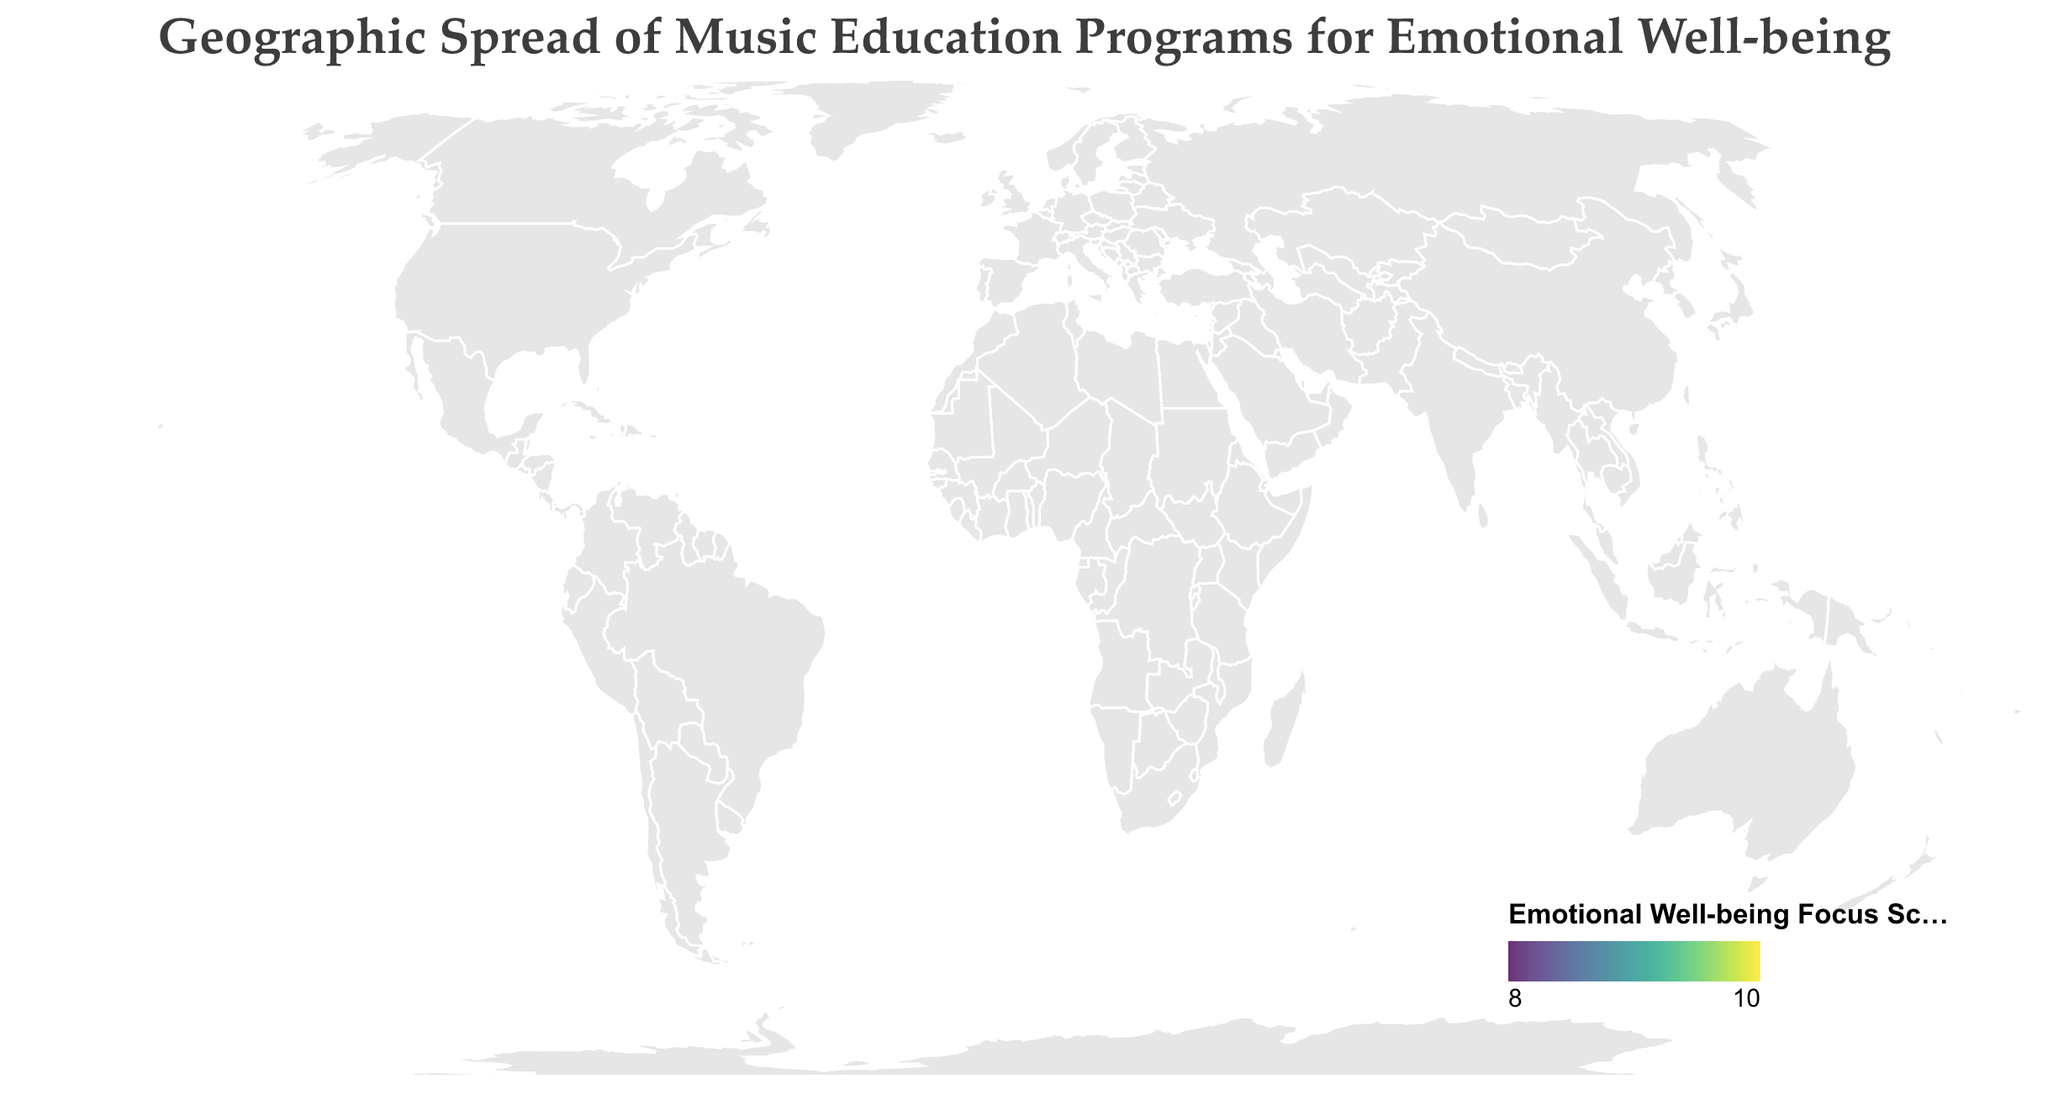What's the title of the figure? The title is displayed at the top of the figure and is written in a prominent font size, making it easy to identify.
Answer: Geographic Spread of Music Education Programs for Emotional Well-being Which city has the highest Emotional Well-being Focus Score? The color gradient representing the Emotional Well-being Focus Score can help identify the city with the highest score. Tokyo has a focus score of 9.5, which is the highest on the scale.
Answer: Tokyo How many countries are represented in the figure? By counting the unique countries listed in the data: United States, United Kingdom, Australia, Canada, Japan, Germany, France, Brazil, South Africa, and India, we find there are 10 countries represented.
Answer: 10 Which program has the most participants? The circle size correlates with the number of participants, with larger circles indicating more participants. "Harmony for the Heart" in New York is the largest circle with 250 participants.
Answer: Harmony for the Heart What is the average Emotional Well-being Focus Score across all programs? The Emotional Well-being Focus Scores are: 8.5, 9.2, 7.8, 8.9, 9.5, 8.2, 8.7, 7.5, 8.1, 9.1. Adding these and dividing by 10 gives: (8.5 + 9.2 + 7.8 + 8.9 + 9.5 + 8.2 + 8.7 + 7.5 + 8.1 + 9.1)/10 = 8.65.
Answer: 8.65 Which two cities have the closest Emotional Well-being Focus Scores? By comparing the scores visually and numerically, Berlin (8.2) and Cape Town (8.1) have the closest scores with a difference of 0.1.
Answer: Berlin and Cape Town How many cities have an Emotional Well-being Focus Score above 9? The scores above 9 are for London (9.2), Tokyo (9.5), and Mumbai (9.1). Hence, three cities have scores above 9.
Answer: 3 Is there a correlation between the number of participants and the Emotional Well-being Focus Score? Visually assessing the size of circles alongside their colors shows no clear correlation, as larger circles (e.g., New York with 250 participants) don't consistently have the highest focus scores. Similarly, smaller circles can have higher scores (e.g., Tokyo with 150 participants).
Answer: No clear correlation Which program in a European city has the highest Emotional Well-being Focus Score? The European cities listed are London, Berlin, and Paris. Among them, "Soul Strings Academy" in London has the highest focus score at 9.2.
Answer: Soul Strings Academy 